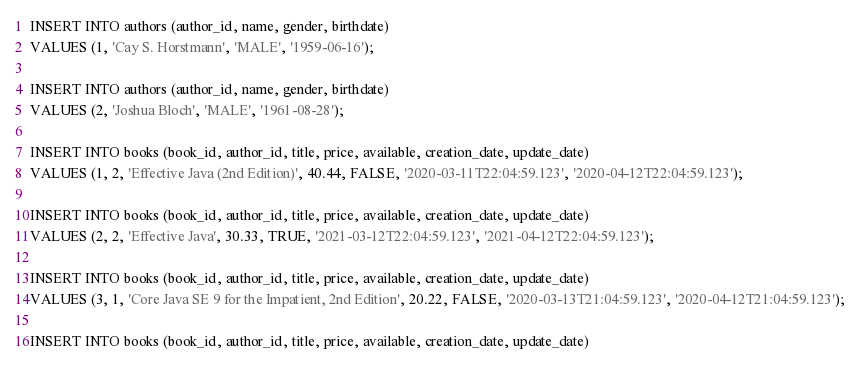<code> <loc_0><loc_0><loc_500><loc_500><_SQL_>INSERT INTO authors (author_id, name, gender, birthdate) 
VALUES (1, 'Cay S. Horstmann', 'MALE', '1959-06-16');

INSERT INTO authors (author_id, name, gender, birthdate) 
VALUES (2, 'Joshua Bloch', 'MALE', '1961-08-28');

INSERT INTO books (book_id, author_id, title, price, available, creation_date, update_date) 
VALUES (1, 2, 'Effective Java (2nd Edition)', 40.44, FALSE, '2020-03-11T22:04:59.123', '2020-04-12T22:04:59.123');

INSERT INTO books (book_id, author_id, title, price, available, creation_date, update_date) 
VALUES (2, 2, 'Effective Java', 30.33, TRUE, '2021-03-12T22:04:59.123', '2021-04-12T22:04:59.123');

INSERT INTO books (book_id, author_id, title, price, available, creation_date, update_date) 
VALUES (3, 1, 'Core Java SE 9 for the Impatient, 2nd Edition', 20.22, FALSE, '2020-03-13T21:04:59.123', '2020-04-12T21:04:59.123');

INSERT INTO books (book_id, author_id, title, price, available, creation_date, update_date) </code> 